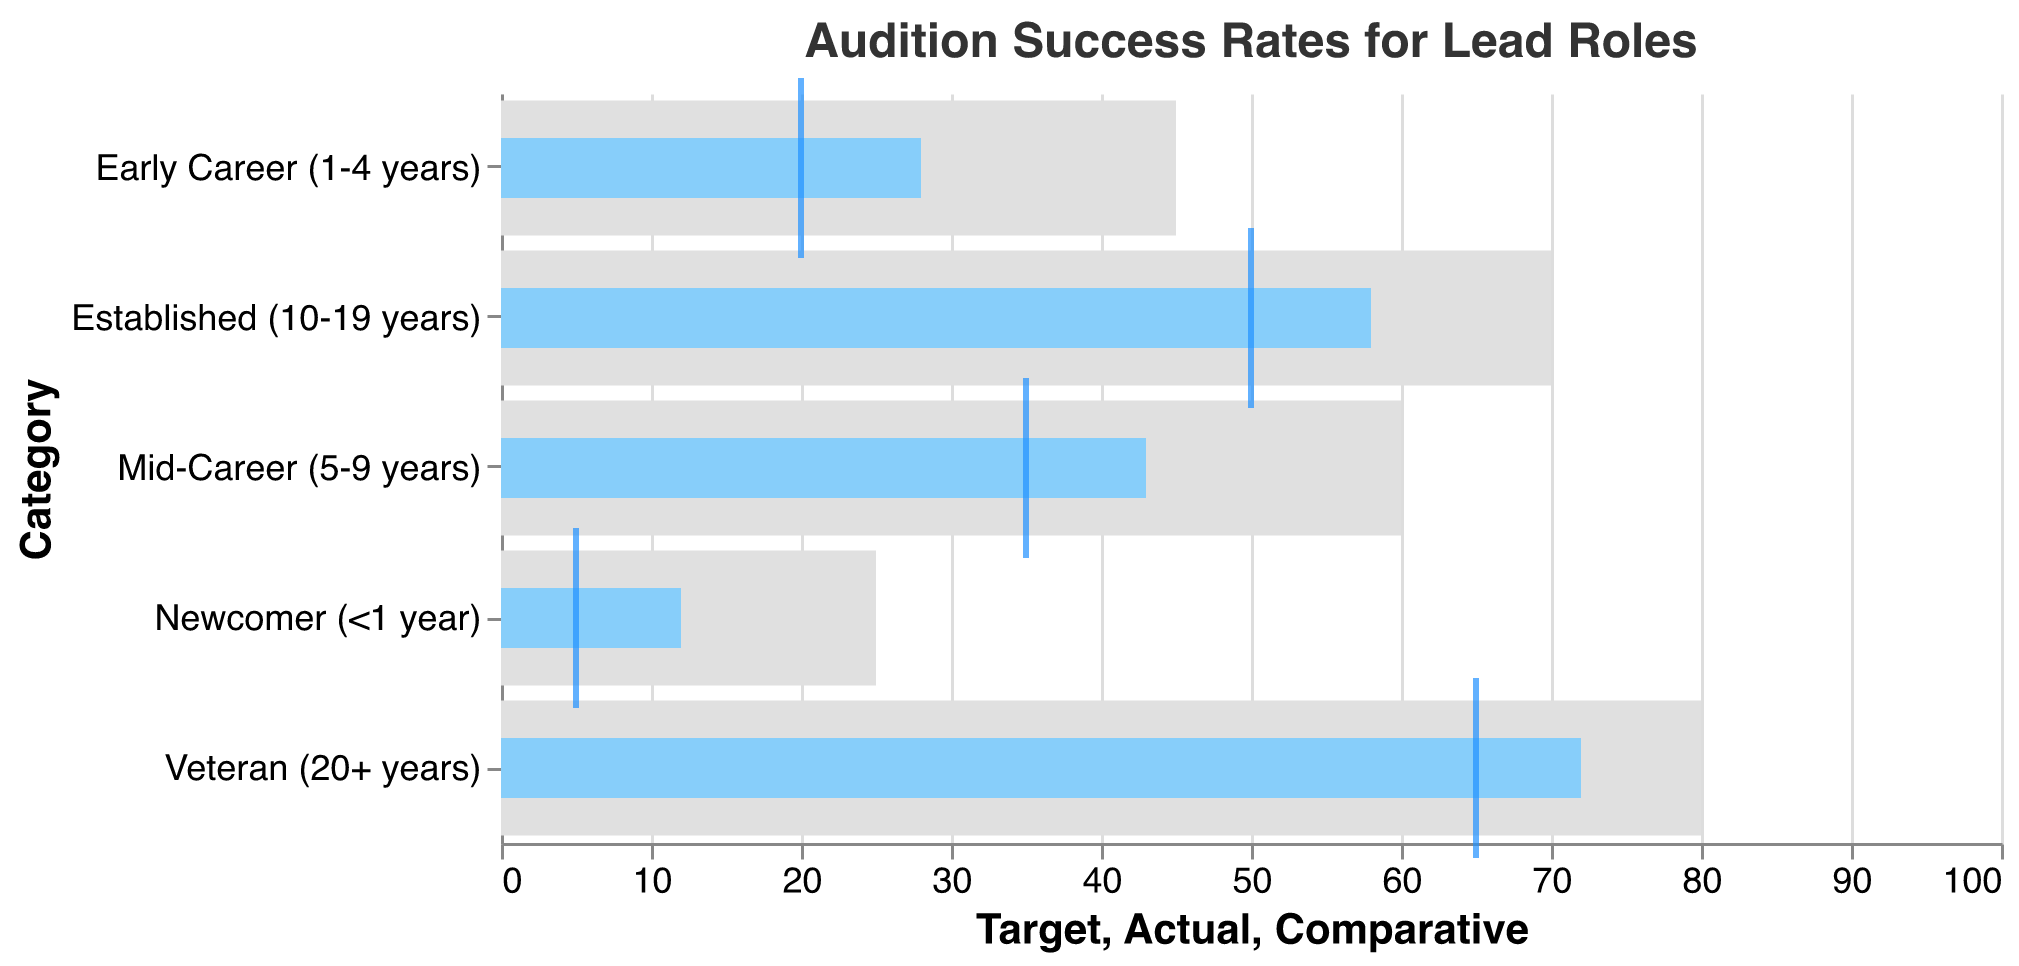What's the title of the chart? The title of the chart is displayed at the top and reads "Audition Success Rates for Lead Roles," indicating the subject of the data visualized.
Answer: Audition Success Rates for Lead Roles How many categories are shown in the chart? The chart displays categories on the y-axis; counting them reveals there are five categories in total.
Answer: 5 Which category has the highest actual audition success rate? The bar representing "Veteran (20+ years)" extends the farthest to the right, indicating the highest actual success rate.
Answer: Veteran (20+ years) What is the difference between the actual and target success rates for the 'Mid-Career (5-9 years)' category? The target success rate is 60, and the actual success rate is 43. The difference is calculated by subtracting the actual rate from the target rate (60 - 43).
Answer: 17 In which category is the actual success rate closest to the comparative success rate? The actual and comparative success rates are closest in the "Veteran (20+ years)" category, where the actual rate is 72 and the comparative rate is 65, with a difference of 7.
Answer: Veteran (20+ years) How does the actual success rate for 'Newcomer (<1 year)' compare to its target success rate? The actual success rate for 'Newcomer (<1 year)' is 12, while the target success rate is 25. By comparing both, it is clear that the actual rate is less than half of the target.
Answer: Less than half Which category has the smallest comparative success rate, and what is it? The tick representing the smallest comparative success rate corresponds to the "Newcomer (<1 year)" category, shown at 5.
Answer: Newcomer (<1 year), 5 What is the average target success rate across all categories? The total target success rates can be calculated as 80 + 70 + 60 + 45 + 25 = 280, and then the average is 280 divided by 5 categories.
Answer: 56 Between 'Early Career (1-4 years)' and 'Newcomer (<1 year),' which category shows a bigger gap between actual and comparative success rates? The gap for 'Early Career (1-4 years)' is 28 (actual) - 20 (comparative) = 8, whereas for 'Newcomer (<1 year)' it is 12 (actual) - 5 (comparative) = 7. Hence, 'Early Career (1-4 years)' shows a bigger gap.
Answer: Early Career (1-4 years) What do the light grey bars represent in the chart? The light grey bars illustrate the target success rates for each category, providing a visual benchmark for the actual and comparative rates.
Answer: Target success rates 